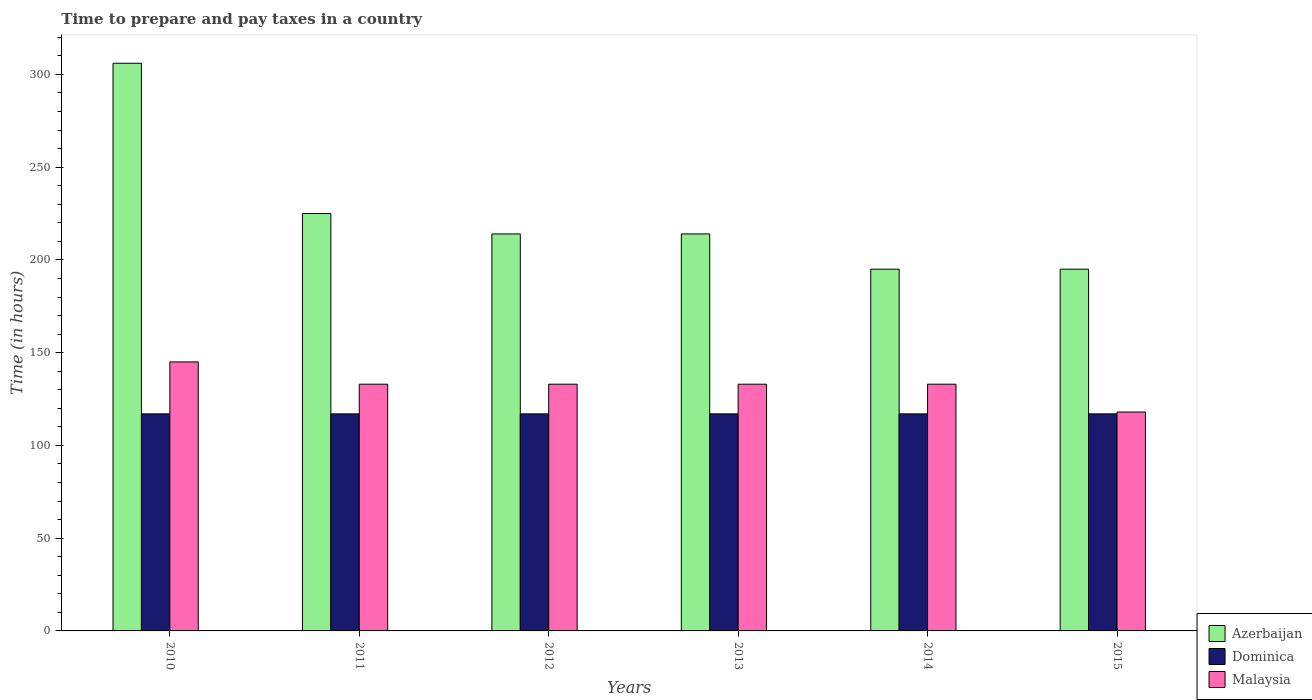How many different coloured bars are there?
Your answer should be very brief. 3. What is the label of the 6th group of bars from the left?
Your answer should be very brief. 2015. In how many cases, is the number of bars for a given year not equal to the number of legend labels?
Keep it short and to the point. 0. What is the number of hours required to prepare and pay taxes in Dominica in 2010?
Offer a terse response. 117. Across all years, what is the maximum number of hours required to prepare and pay taxes in Dominica?
Give a very brief answer. 117. Across all years, what is the minimum number of hours required to prepare and pay taxes in Dominica?
Give a very brief answer. 117. What is the total number of hours required to prepare and pay taxes in Malaysia in the graph?
Your answer should be very brief. 795. What is the difference between the number of hours required to prepare and pay taxes in Malaysia in 2010 and that in 2014?
Your response must be concise. 12. What is the difference between the number of hours required to prepare and pay taxes in Dominica in 2010 and the number of hours required to prepare and pay taxes in Azerbaijan in 2014?
Your response must be concise. -78. What is the average number of hours required to prepare and pay taxes in Azerbaijan per year?
Provide a short and direct response. 224.83. In the year 2012, what is the difference between the number of hours required to prepare and pay taxes in Malaysia and number of hours required to prepare and pay taxes in Azerbaijan?
Your answer should be very brief. -81. What is the ratio of the number of hours required to prepare and pay taxes in Azerbaijan in 2010 to that in 2011?
Ensure brevity in your answer.  1.36. Is the difference between the number of hours required to prepare and pay taxes in Malaysia in 2010 and 2014 greater than the difference between the number of hours required to prepare and pay taxes in Azerbaijan in 2010 and 2014?
Offer a very short reply. No. What is the difference between the highest and the second highest number of hours required to prepare and pay taxes in Azerbaijan?
Provide a succinct answer. 81. What is the difference between the highest and the lowest number of hours required to prepare and pay taxes in Azerbaijan?
Offer a very short reply. 111. What does the 2nd bar from the left in 2011 represents?
Give a very brief answer. Dominica. What does the 2nd bar from the right in 2013 represents?
Give a very brief answer. Dominica. Are the values on the major ticks of Y-axis written in scientific E-notation?
Make the answer very short. No. Does the graph contain grids?
Give a very brief answer. No. How many legend labels are there?
Provide a short and direct response. 3. What is the title of the graph?
Your answer should be very brief. Time to prepare and pay taxes in a country. Does "Guyana" appear as one of the legend labels in the graph?
Ensure brevity in your answer.  No. What is the label or title of the Y-axis?
Make the answer very short. Time (in hours). What is the Time (in hours) in Azerbaijan in 2010?
Your answer should be compact. 306. What is the Time (in hours) in Dominica in 2010?
Provide a short and direct response. 117. What is the Time (in hours) of Malaysia in 2010?
Provide a short and direct response. 145. What is the Time (in hours) of Azerbaijan in 2011?
Provide a succinct answer. 225. What is the Time (in hours) in Dominica in 2011?
Your answer should be compact. 117. What is the Time (in hours) in Malaysia in 2011?
Provide a short and direct response. 133. What is the Time (in hours) in Azerbaijan in 2012?
Your answer should be compact. 214. What is the Time (in hours) of Dominica in 2012?
Your response must be concise. 117. What is the Time (in hours) of Malaysia in 2012?
Your answer should be compact. 133. What is the Time (in hours) of Azerbaijan in 2013?
Offer a very short reply. 214. What is the Time (in hours) of Dominica in 2013?
Give a very brief answer. 117. What is the Time (in hours) in Malaysia in 2013?
Make the answer very short. 133. What is the Time (in hours) of Azerbaijan in 2014?
Keep it short and to the point. 195. What is the Time (in hours) of Dominica in 2014?
Keep it short and to the point. 117. What is the Time (in hours) in Malaysia in 2014?
Provide a short and direct response. 133. What is the Time (in hours) of Azerbaijan in 2015?
Your answer should be very brief. 195. What is the Time (in hours) of Dominica in 2015?
Provide a succinct answer. 117. What is the Time (in hours) of Malaysia in 2015?
Give a very brief answer. 118. Across all years, what is the maximum Time (in hours) in Azerbaijan?
Offer a very short reply. 306. Across all years, what is the maximum Time (in hours) in Dominica?
Provide a short and direct response. 117. Across all years, what is the maximum Time (in hours) of Malaysia?
Your answer should be very brief. 145. Across all years, what is the minimum Time (in hours) in Azerbaijan?
Offer a terse response. 195. Across all years, what is the minimum Time (in hours) in Dominica?
Your response must be concise. 117. Across all years, what is the minimum Time (in hours) of Malaysia?
Your response must be concise. 118. What is the total Time (in hours) of Azerbaijan in the graph?
Offer a terse response. 1349. What is the total Time (in hours) of Dominica in the graph?
Provide a short and direct response. 702. What is the total Time (in hours) in Malaysia in the graph?
Offer a very short reply. 795. What is the difference between the Time (in hours) of Azerbaijan in 2010 and that in 2011?
Ensure brevity in your answer.  81. What is the difference between the Time (in hours) of Dominica in 2010 and that in 2011?
Provide a succinct answer. 0. What is the difference between the Time (in hours) of Azerbaijan in 2010 and that in 2012?
Ensure brevity in your answer.  92. What is the difference between the Time (in hours) of Malaysia in 2010 and that in 2012?
Give a very brief answer. 12. What is the difference between the Time (in hours) of Azerbaijan in 2010 and that in 2013?
Provide a succinct answer. 92. What is the difference between the Time (in hours) in Malaysia in 2010 and that in 2013?
Ensure brevity in your answer.  12. What is the difference between the Time (in hours) of Azerbaijan in 2010 and that in 2014?
Your answer should be compact. 111. What is the difference between the Time (in hours) of Malaysia in 2010 and that in 2014?
Offer a very short reply. 12. What is the difference between the Time (in hours) of Azerbaijan in 2010 and that in 2015?
Give a very brief answer. 111. What is the difference between the Time (in hours) of Dominica in 2010 and that in 2015?
Provide a short and direct response. 0. What is the difference between the Time (in hours) of Malaysia in 2010 and that in 2015?
Offer a very short reply. 27. What is the difference between the Time (in hours) in Azerbaijan in 2011 and that in 2012?
Provide a short and direct response. 11. What is the difference between the Time (in hours) in Malaysia in 2011 and that in 2012?
Provide a short and direct response. 0. What is the difference between the Time (in hours) of Malaysia in 2011 and that in 2013?
Provide a short and direct response. 0. What is the difference between the Time (in hours) of Azerbaijan in 2011 and that in 2015?
Your answer should be compact. 30. What is the difference between the Time (in hours) of Azerbaijan in 2012 and that in 2013?
Your response must be concise. 0. What is the difference between the Time (in hours) of Dominica in 2012 and that in 2014?
Offer a very short reply. 0. What is the difference between the Time (in hours) in Dominica in 2012 and that in 2015?
Your answer should be very brief. 0. What is the difference between the Time (in hours) of Malaysia in 2012 and that in 2015?
Your response must be concise. 15. What is the difference between the Time (in hours) of Malaysia in 2013 and that in 2014?
Your answer should be very brief. 0. What is the difference between the Time (in hours) in Azerbaijan in 2013 and that in 2015?
Provide a short and direct response. 19. What is the difference between the Time (in hours) of Azerbaijan in 2014 and that in 2015?
Keep it short and to the point. 0. What is the difference between the Time (in hours) in Malaysia in 2014 and that in 2015?
Keep it short and to the point. 15. What is the difference between the Time (in hours) of Azerbaijan in 2010 and the Time (in hours) of Dominica in 2011?
Give a very brief answer. 189. What is the difference between the Time (in hours) in Azerbaijan in 2010 and the Time (in hours) in Malaysia in 2011?
Offer a very short reply. 173. What is the difference between the Time (in hours) of Azerbaijan in 2010 and the Time (in hours) of Dominica in 2012?
Offer a very short reply. 189. What is the difference between the Time (in hours) in Azerbaijan in 2010 and the Time (in hours) in Malaysia in 2012?
Your response must be concise. 173. What is the difference between the Time (in hours) in Dominica in 2010 and the Time (in hours) in Malaysia in 2012?
Your answer should be very brief. -16. What is the difference between the Time (in hours) of Azerbaijan in 2010 and the Time (in hours) of Dominica in 2013?
Offer a very short reply. 189. What is the difference between the Time (in hours) in Azerbaijan in 2010 and the Time (in hours) in Malaysia in 2013?
Your answer should be very brief. 173. What is the difference between the Time (in hours) in Dominica in 2010 and the Time (in hours) in Malaysia in 2013?
Keep it short and to the point. -16. What is the difference between the Time (in hours) in Azerbaijan in 2010 and the Time (in hours) in Dominica in 2014?
Keep it short and to the point. 189. What is the difference between the Time (in hours) of Azerbaijan in 2010 and the Time (in hours) of Malaysia in 2014?
Your answer should be compact. 173. What is the difference between the Time (in hours) of Dominica in 2010 and the Time (in hours) of Malaysia in 2014?
Provide a succinct answer. -16. What is the difference between the Time (in hours) in Azerbaijan in 2010 and the Time (in hours) in Dominica in 2015?
Provide a succinct answer. 189. What is the difference between the Time (in hours) of Azerbaijan in 2010 and the Time (in hours) of Malaysia in 2015?
Offer a very short reply. 188. What is the difference between the Time (in hours) of Dominica in 2010 and the Time (in hours) of Malaysia in 2015?
Your answer should be very brief. -1. What is the difference between the Time (in hours) of Azerbaijan in 2011 and the Time (in hours) of Dominica in 2012?
Provide a short and direct response. 108. What is the difference between the Time (in hours) in Azerbaijan in 2011 and the Time (in hours) in Malaysia in 2012?
Your answer should be very brief. 92. What is the difference between the Time (in hours) of Dominica in 2011 and the Time (in hours) of Malaysia in 2012?
Ensure brevity in your answer.  -16. What is the difference between the Time (in hours) of Azerbaijan in 2011 and the Time (in hours) of Dominica in 2013?
Ensure brevity in your answer.  108. What is the difference between the Time (in hours) of Azerbaijan in 2011 and the Time (in hours) of Malaysia in 2013?
Provide a short and direct response. 92. What is the difference between the Time (in hours) in Azerbaijan in 2011 and the Time (in hours) in Dominica in 2014?
Make the answer very short. 108. What is the difference between the Time (in hours) in Azerbaijan in 2011 and the Time (in hours) in Malaysia in 2014?
Provide a short and direct response. 92. What is the difference between the Time (in hours) in Dominica in 2011 and the Time (in hours) in Malaysia in 2014?
Ensure brevity in your answer.  -16. What is the difference between the Time (in hours) in Azerbaijan in 2011 and the Time (in hours) in Dominica in 2015?
Ensure brevity in your answer.  108. What is the difference between the Time (in hours) in Azerbaijan in 2011 and the Time (in hours) in Malaysia in 2015?
Offer a terse response. 107. What is the difference between the Time (in hours) of Dominica in 2011 and the Time (in hours) of Malaysia in 2015?
Provide a short and direct response. -1. What is the difference between the Time (in hours) of Azerbaijan in 2012 and the Time (in hours) of Dominica in 2013?
Provide a succinct answer. 97. What is the difference between the Time (in hours) of Azerbaijan in 2012 and the Time (in hours) of Malaysia in 2013?
Keep it short and to the point. 81. What is the difference between the Time (in hours) in Dominica in 2012 and the Time (in hours) in Malaysia in 2013?
Keep it short and to the point. -16. What is the difference between the Time (in hours) of Azerbaijan in 2012 and the Time (in hours) of Dominica in 2014?
Give a very brief answer. 97. What is the difference between the Time (in hours) in Dominica in 2012 and the Time (in hours) in Malaysia in 2014?
Offer a very short reply. -16. What is the difference between the Time (in hours) of Azerbaijan in 2012 and the Time (in hours) of Dominica in 2015?
Your response must be concise. 97. What is the difference between the Time (in hours) in Azerbaijan in 2012 and the Time (in hours) in Malaysia in 2015?
Provide a short and direct response. 96. What is the difference between the Time (in hours) of Azerbaijan in 2013 and the Time (in hours) of Dominica in 2014?
Your answer should be very brief. 97. What is the difference between the Time (in hours) in Azerbaijan in 2013 and the Time (in hours) in Malaysia in 2014?
Ensure brevity in your answer.  81. What is the difference between the Time (in hours) of Azerbaijan in 2013 and the Time (in hours) of Dominica in 2015?
Provide a succinct answer. 97. What is the difference between the Time (in hours) of Azerbaijan in 2013 and the Time (in hours) of Malaysia in 2015?
Your response must be concise. 96. What is the difference between the Time (in hours) of Azerbaijan in 2014 and the Time (in hours) of Malaysia in 2015?
Your response must be concise. 77. What is the average Time (in hours) in Azerbaijan per year?
Ensure brevity in your answer.  224.83. What is the average Time (in hours) in Dominica per year?
Make the answer very short. 117. What is the average Time (in hours) in Malaysia per year?
Your response must be concise. 132.5. In the year 2010, what is the difference between the Time (in hours) of Azerbaijan and Time (in hours) of Dominica?
Offer a terse response. 189. In the year 2010, what is the difference between the Time (in hours) of Azerbaijan and Time (in hours) of Malaysia?
Your response must be concise. 161. In the year 2011, what is the difference between the Time (in hours) in Azerbaijan and Time (in hours) in Dominica?
Make the answer very short. 108. In the year 2011, what is the difference between the Time (in hours) of Azerbaijan and Time (in hours) of Malaysia?
Your answer should be compact. 92. In the year 2011, what is the difference between the Time (in hours) of Dominica and Time (in hours) of Malaysia?
Offer a terse response. -16. In the year 2012, what is the difference between the Time (in hours) of Azerbaijan and Time (in hours) of Dominica?
Provide a short and direct response. 97. In the year 2012, what is the difference between the Time (in hours) of Azerbaijan and Time (in hours) of Malaysia?
Provide a succinct answer. 81. In the year 2013, what is the difference between the Time (in hours) of Azerbaijan and Time (in hours) of Dominica?
Keep it short and to the point. 97. In the year 2014, what is the difference between the Time (in hours) in Azerbaijan and Time (in hours) in Dominica?
Your answer should be compact. 78. In the year 2014, what is the difference between the Time (in hours) of Dominica and Time (in hours) of Malaysia?
Make the answer very short. -16. In the year 2015, what is the difference between the Time (in hours) in Azerbaijan and Time (in hours) in Dominica?
Provide a short and direct response. 78. In the year 2015, what is the difference between the Time (in hours) in Azerbaijan and Time (in hours) in Malaysia?
Offer a very short reply. 77. What is the ratio of the Time (in hours) in Azerbaijan in 2010 to that in 2011?
Keep it short and to the point. 1.36. What is the ratio of the Time (in hours) of Dominica in 2010 to that in 2011?
Ensure brevity in your answer.  1. What is the ratio of the Time (in hours) in Malaysia in 2010 to that in 2011?
Give a very brief answer. 1.09. What is the ratio of the Time (in hours) of Azerbaijan in 2010 to that in 2012?
Ensure brevity in your answer.  1.43. What is the ratio of the Time (in hours) of Malaysia in 2010 to that in 2012?
Provide a short and direct response. 1.09. What is the ratio of the Time (in hours) of Azerbaijan in 2010 to that in 2013?
Give a very brief answer. 1.43. What is the ratio of the Time (in hours) in Malaysia in 2010 to that in 2013?
Provide a succinct answer. 1.09. What is the ratio of the Time (in hours) in Azerbaijan in 2010 to that in 2014?
Your answer should be compact. 1.57. What is the ratio of the Time (in hours) in Dominica in 2010 to that in 2014?
Offer a very short reply. 1. What is the ratio of the Time (in hours) in Malaysia in 2010 to that in 2014?
Offer a very short reply. 1.09. What is the ratio of the Time (in hours) in Azerbaijan in 2010 to that in 2015?
Provide a succinct answer. 1.57. What is the ratio of the Time (in hours) of Dominica in 2010 to that in 2015?
Keep it short and to the point. 1. What is the ratio of the Time (in hours) in Malaysia in 2010 to that in 2015?
Provide a succinct answer. 1.23. What is the ratio of the Time (in hours) of Azerbaijan in 2011 to that in 2012?
Offer a very short reply. 1.05. What is the ratio of the Time (in hours) of Azerbaijan in 2011 to that in 2013?
Keep it short and to the point. 1.05. What is the ratio of the Time (in hours) of Malaysia in 2011 to that in 2013?
Provide a succinct answer. 1. What is the ratio of the Time (in hours) in Azerbaijan in 2011 to that in 2014?
Provide a short and direct response. 1.15. What is the ratio of the Time (in hours) of Azerbaijan in 2011 to that in 2015?
Your answer should be compact. 1.15. What is the ratio of the Time (in hours) of Malaysia in 2011 to that in 2015?
Offer a terse response. 1.13. What is the ratio of the Time (in hours) of Azerbaijan in 2012 to that in 2013?
Your response must be concise. 1. What is the ratio of the Time (in hours) in Dominica in 2012 to that in 2013?
Your response must be concise. 1. What is the ratio of the Time (in hours) in Malaysia in 2012 to that in 2013?
Your response must be concise. 1. What is the ratio of the Time (in hours) in Azerbaijan in 2012 to that in 2014?
Keep it short and to the point. 1.1. What is the ratio of the Time (in hours) in Dominica in 2012 to that in 2014?
Give a very brief answer. 1. What is the ratio of the Time (in hours) in Azerbaijan in 2012 to that in 2015?
Your answer should be very brief. 1.1. What is the ratio of the Time (in hours) in Dominica in 2012 to that in 2015?
Ensure brevity in your answer.  1. What is the ratio of the Time (in hours) in Malaysia in 2012 to that in 2015?
Keep it short and to the point. 1.13. What is the ratio of the Time (in hours) in Azerbaijan in 2013 to that in 2014?
Offer a very short reply. 1.1. What is the ratio of the Time (in hours) in Dominica in 2013 to that in 2014?
Your answer should be very brief. 1. What is the ratio of the Time (in hours) in Malaysia in 2013 to that in 2014?
Offer a very short reply. 1. What is the ratio of the Time (in hours) of Azerbaijan in 2013 to that in 2015?
Your answer should be compact. 1.1. What is the ratio of the Time (in hours) of Dominica in 2013 to that in 2015?
Keep it short and to the point. 1. What is the ratio of the Time (in hours) of Malaysia in 2013 to that in 2015?
Keep it short and to the point. 1.13. What is the ratio of the Time (in hours) of Dominica in 2014 to that in 2015?
Your answer should be very brief. 1. What is the ratio of the Time (in hours) in Malaysia in 2014 to that in 2015?
Offer a very short reply. 1.13. What is the difference between the highest and the second highest Time (in hours) in Azerbaijan?
Ensure brevity in your answer.  81. What is the difference between the highest and the second highest Time (in hours) in Dominica?
Give a very brief answer. 0. What is the difference between the highest and the second highest Time (in hours) in Malaysia?
Offer a terse response. 12. What is the difference between the highest and the lowest Time (in hours) of Azerbaijan?
Offer a terse response. 111. What is the difference between the highest and the lowest Time (in hours) of Malaysia?
Your response must be concise. 27. 